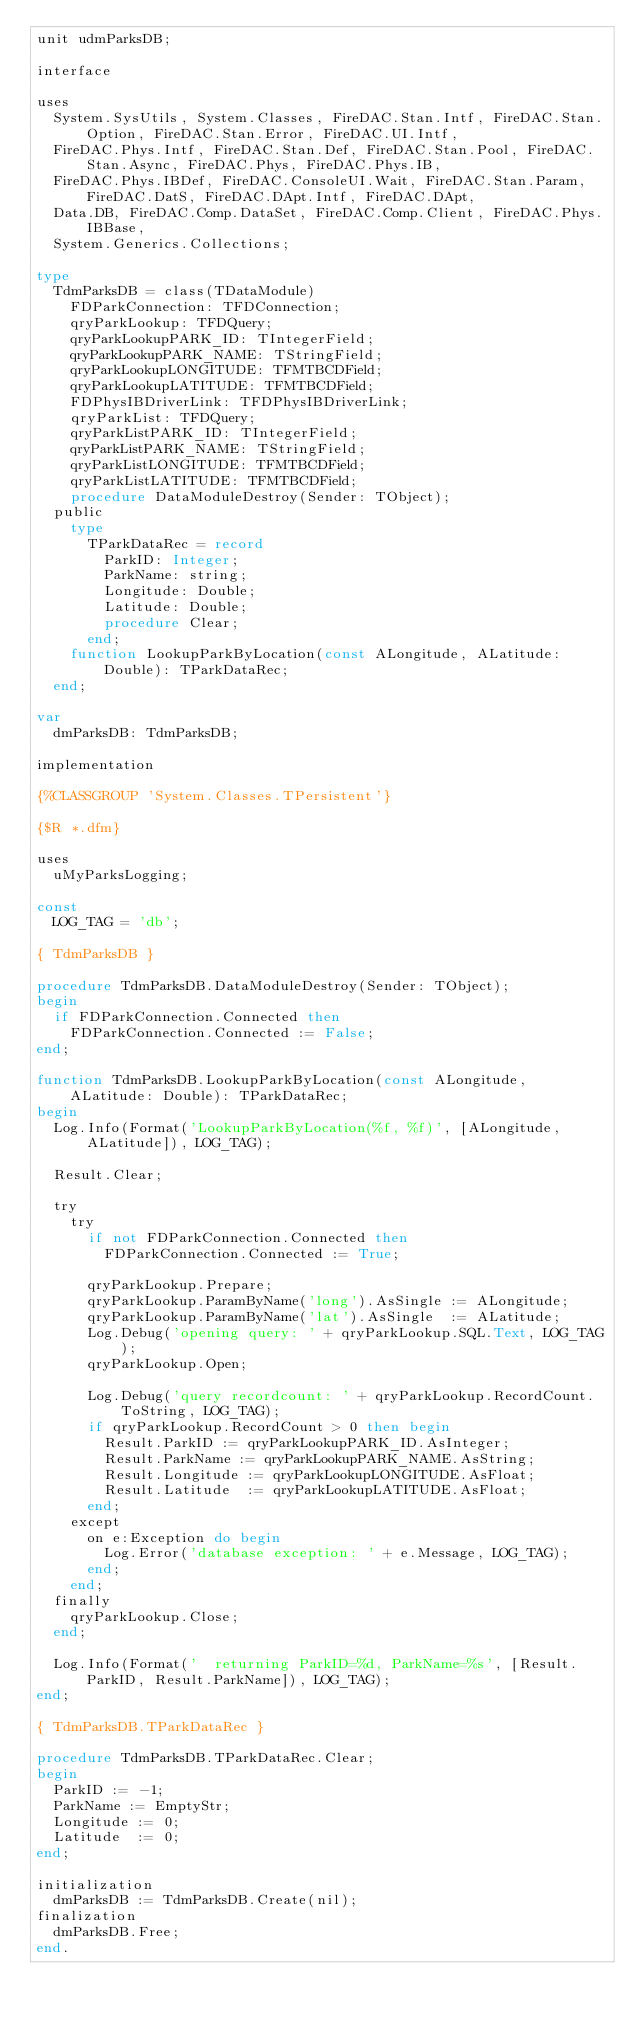<code> <loc_0><loc_0><loc_500><loc_500><_Pascal_>unit udmParksDB;

interface

uses
  System.SysUtils, System.Classes, FireDAC.Stan.Intf, FireDAC.Stan.Option, FireDAC.Stan.Error, FireDAC.UI.Intf,
  FireDAC.Phys.Intf, FireDAC.Stan.Def, FireDAC.Stan.Pool, FireDAC.Stan.Async, FireDAC.Phys, FireDAC.Phys.IB,
  FireDAC.Phys.IBDef, FireDAC.ConsoleUI.Wait, FireDAC.Stan.Param, FireDAC.DatS, FireDAC.DApt.Intf, FireDAC.DApt,
  Data.DB, FireDAC.Comp.DataSet, FireDAC.Comp.Client, FireDAC.Phys.IBBase,
  System.Generics.Collections;

type
  TdmParksDB = class(TDataModule)
    FDParkConnection: TFDConnection;
    qryParkLookup: TFDQuery;
    qryParkLookupPARK_ID: TIntegerField;
    qryParkLookupPARK_NAME: TStringField;
    qryParkLookupLONGITUDE: TFMTBCDField;
    qryParkLookupLATITUDE: TFMTBCDField;
    FDPhysIBDriverLink: TFDPhysIBDriverLink;
    qryParkList: TFDQuery;
    qryParkListPARK_ID: TIntegerField;
    qryParkListPARK_NAME: TStringField;
    qryParkListLONGITUDE: TFMTBCDField;
    qryParkListLATITUDE: TFMTBCDField;
    procedure DataModuleDestroy(Sender: TObject);
  public
    type
      TParkDataRec = record
        ParkID: Integer;
        ParkName: string;
        Longitude: Double;
        Latitude: Double;
        procedure Clear;
      end;
    function LookupParkByLocation(const ALongitude, ALatitude: Double): TParkDataRec;
  end;

var
  dmParksDB: TdmParksDB;

implementation

{%CLASSGROUP 'System.Classes.TPersistent'}

{$R *.dfm}

uses
  uMyParksLogging;

const
  LOG_TAG = 'db';

{ TdmParksDB }

procedure TdmParksDB.DataModuleDestroy(Sender: TObject);
begin
  if FDParkConnection.Connected then
    FDParkConnection.Connected := False;
end;

function TdmParksDB.LookupParkByLocation(const ALongitude, ALatitude: Double): TParkDataRec;
begin
  Log.Info(Format('LookupParkByLocation(%f, %f)', [ALongitude, ALatitude]), LOG_TAG);

  Result.Clear;

  try
    try
      if not FDParkConnection.Connected then
        FDParkConnection.Connected := True;

      qryParkLookup.Prepare;
      qryParkLookup.ParamByName('long').AsSingle := ALongitude;
      qryParkLookup.ParamByName('lat').AsSingle  := ALatitude;
      Log.Debug('opening query: ' + qryParkLookup.SQL.Text, LOG_TAG);
      qryParkLookup.Open;

      Log.Debug('query recordcount: ' + qryParkLookup.RecordCount.ToString, LOG_TAG);
      if qryParkLookup.RecordCount > 0 then begin
        Result.ParkID := qryParkLookupPARK_ID.AsInteger;
        Result.ParkName := qryParkLookupPARK_NAME.AsString;
        Result.Longitude := qryParkLookupLONGITUDE.AsFloat;
        Result.Latitude  := qryParkLookupLATITUDE.AsFloat;
      end;
    except
      on e:Exception do begin
        Log.Error('database exception: ' + e.Message, LOG_TAG);
      end;
    end;
  finally
    qryParkLookup.Close;
  end;

  Log.Info(Format('  returning ParkID=%d, ParkName=%s', [Result.ParkID, Result.ParkName]), LOG_TAG);
end;

{ TdmParksDB.TParkDataRec }

procedure TdmParksDB.TParkDataRec.Clear;
begin
  ParkID := -1;
  ParkName := EmptyStr;
  Longitude := 0;
  Latitude  := 0;
end;

initialization
  dmParksDB := TdmParksDB.Create(nil);
finalization
  dmParksDB.Free;
end.
</code> 